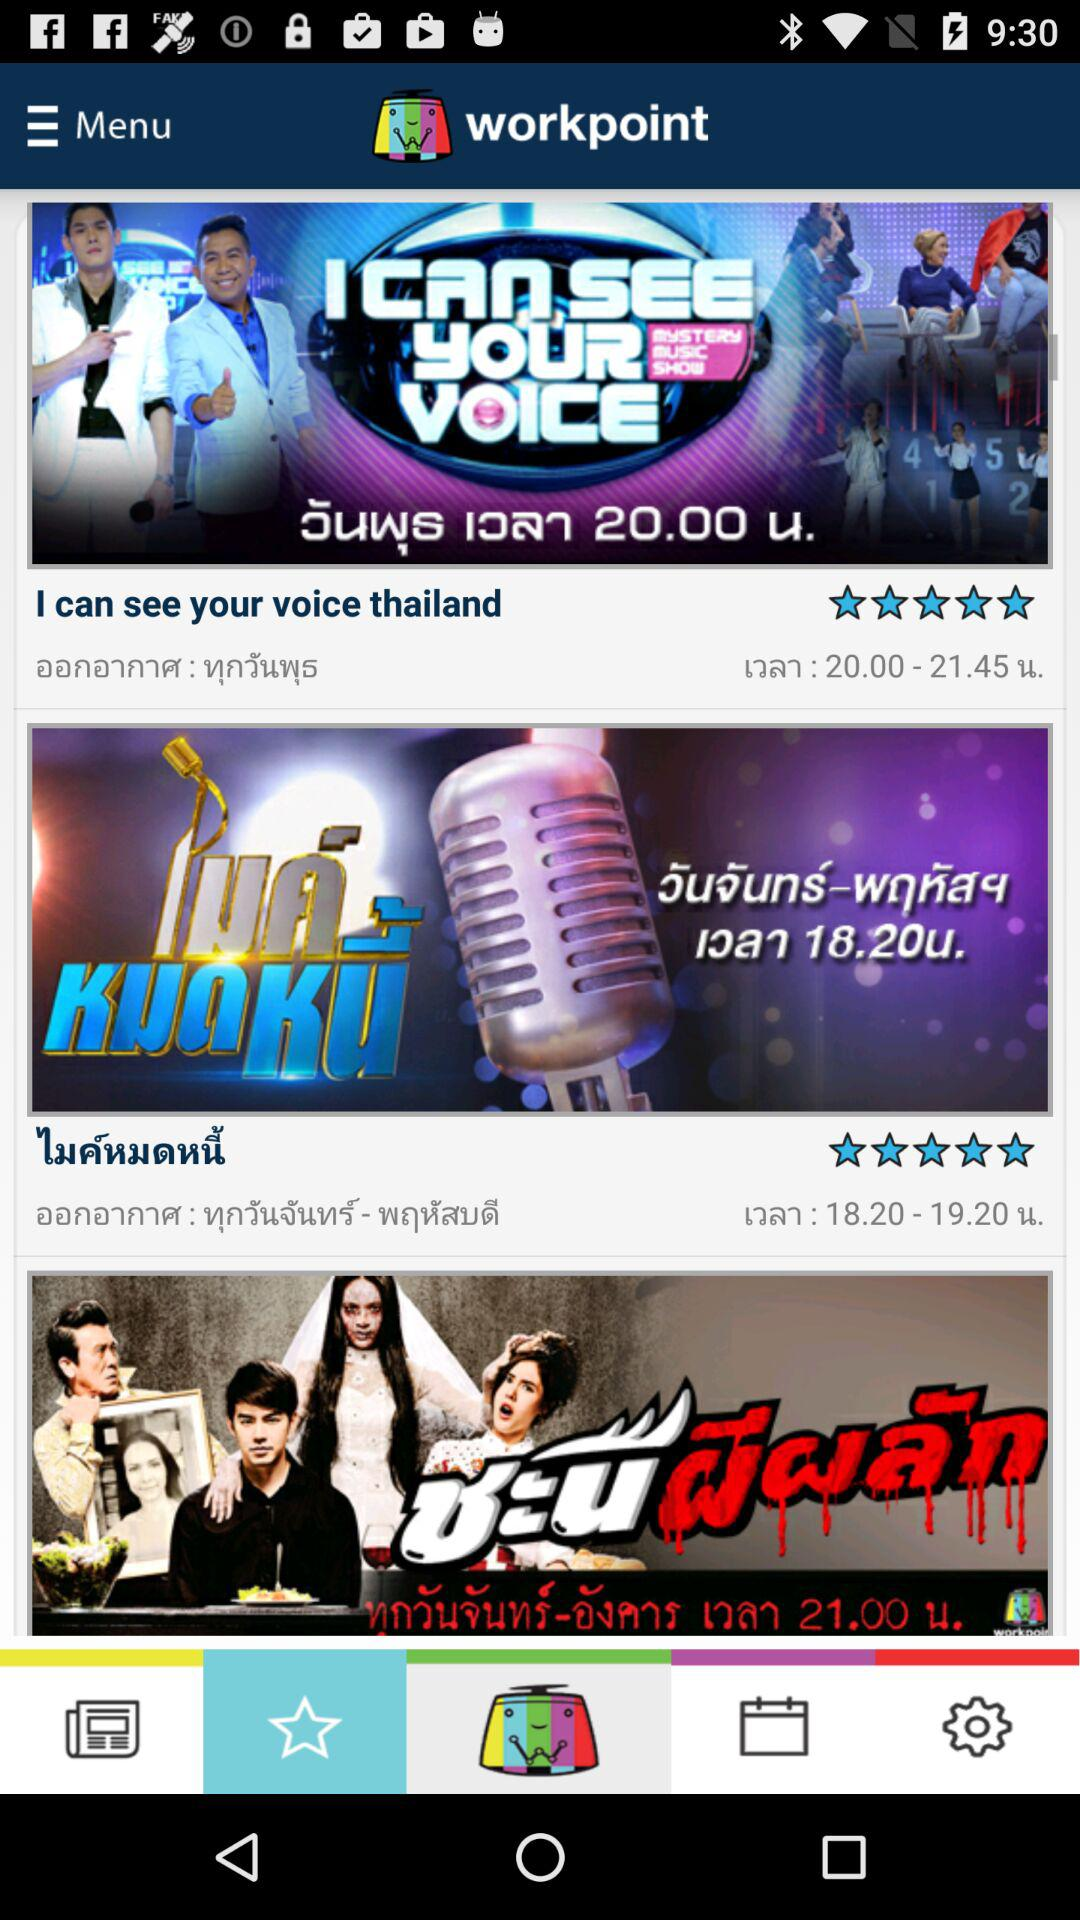What is the star rating of "I can see your voice thailand"? The star rating is 5 stars. 